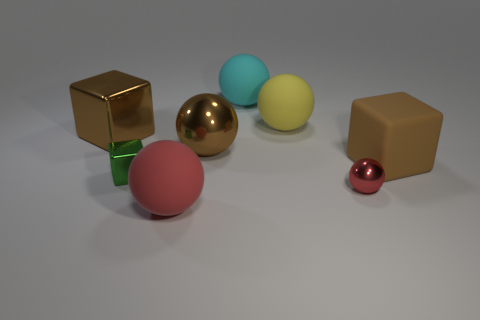The other ball that is the same color as the small shiny sphere is what size?
Provide a short and direct response. Large. The object that is the same color as the small metal sphere is what shape?
Provide a succinct answer. Sphere. What is the shape of the yellow object that is behind the tiny thing that is on the right side of the cyan rubber thing?
Offer a terse response. Sphere. Is the number of large brown objects to the right of the tiny cube greater than the number of tiny blue matte cylinders?
Give a very brief answer. Yes. There is a brown object to the right of the big yellow object; does it have the same shape as the green object?
Your answer should be compact. Yes. Is there another large matte object of the same shape as the big cyan rubber object?
Provide a succinct answer. Yes. How many things are red things that are on the left side of the cyan rubber object or large matte spheres?
Provide a short and direct response. 3. Is the number of big yellow balls greater than the number of gray metallic blocks?
Make the answer very short. Yes. Is there a block of the same size as the brown rubber thing?
Your response must be concise. Yes. How many objects are things that are in front of the tiny cube or spheres right of the large yellow rubber ball?
Provide a succinct answer. 2. 